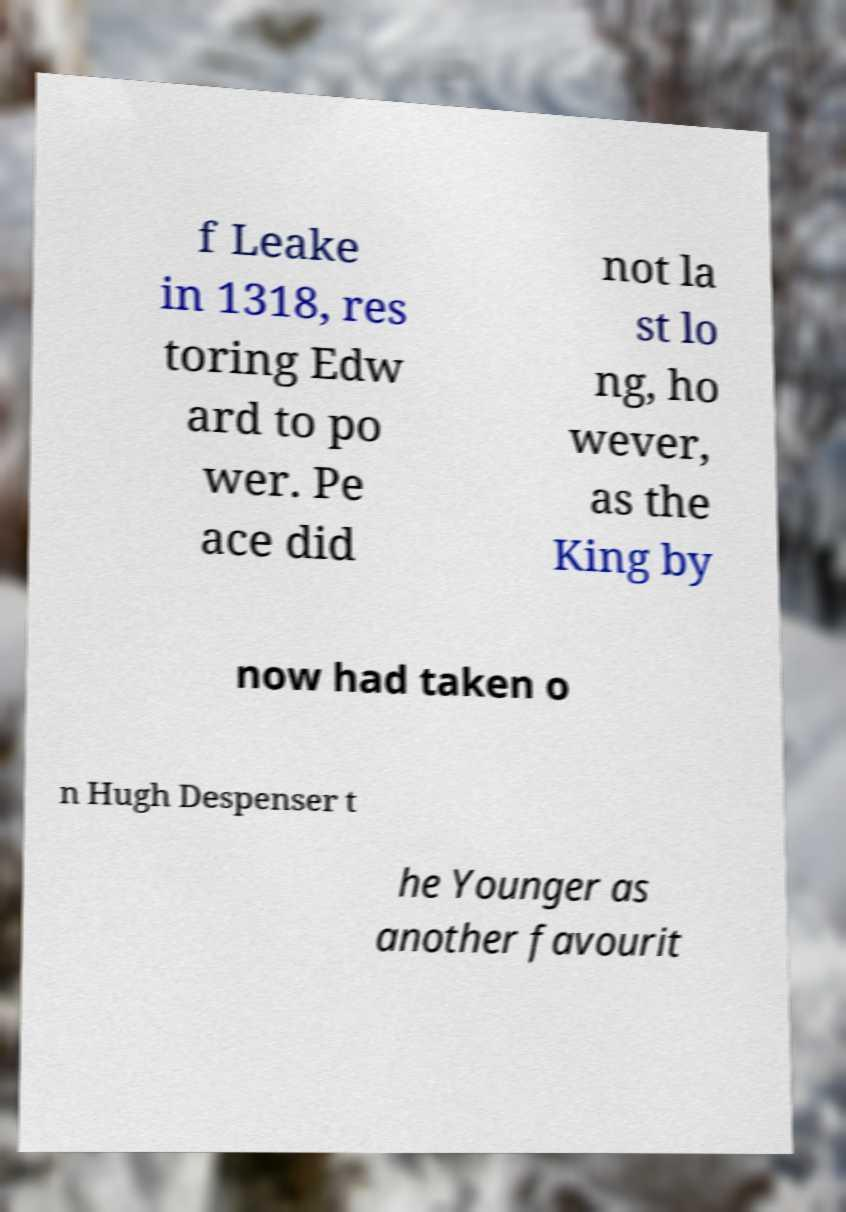Please read and relay the text visible in this image. What does it say? f Leake in 1318, res toring Edw ard to po wer. Pe ace did not la st lo ng, ho wever, as the King by now had taken o n Hugh Despenser t he Younger as another favourit 